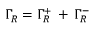<formula> <loc_0><loc_0><loc_500><loc_500>\Gamma _ { R } = \Gamma _ { R } ^ { + } \, + \, \Gamma _ { R } ^ { - }</formula> 